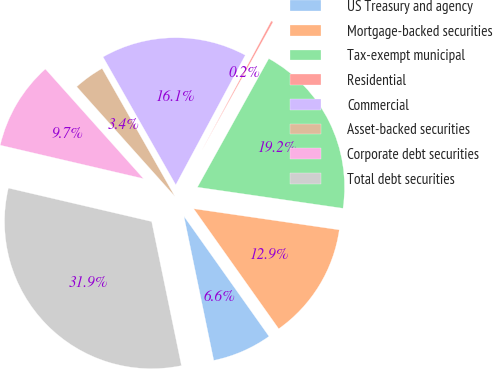Convert chart to OTSL. <chart><loc_0><loc_0><loc_500><loc_500><pie_chart><fcel>US Treasury and agency<fcel>Mortgage-backed securities<fcel>Tax-exempt municipal<fcel>Residential<fcel>Commercial<fcel>Asset-backed securities<fcel>Corporate debt securities<fcel>Total debt securities<nl><fcel>6.56%<fcel>12.9%<fcel>19.23%<fcel>0.23%<fcel>16.06%<fcel>3.39%<fcel>9.73%<fcel>31.9%<nl></chart> 